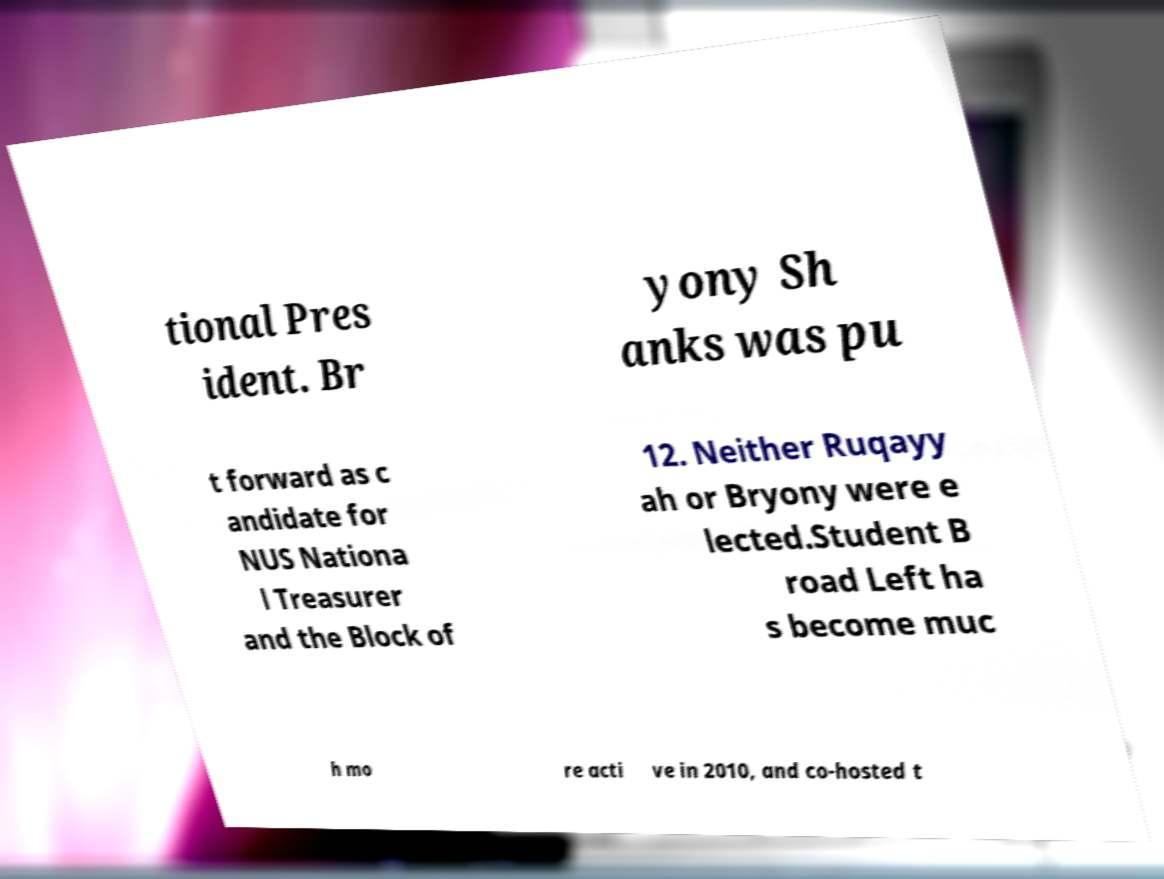Can you read and provide the text displayed in the image?This photo seems to have some interesting text. Can you extract and type it out for me? tional Pres ident. Br yony Sh anks was pu t forward as c andidate for NUS Nationa l Treasurer and the Block of 12. Neither Ruqayy ah or Bryony were e lected.Student B road Left ha s become muc h mo re acti ve in 2010, and co-hosted t 